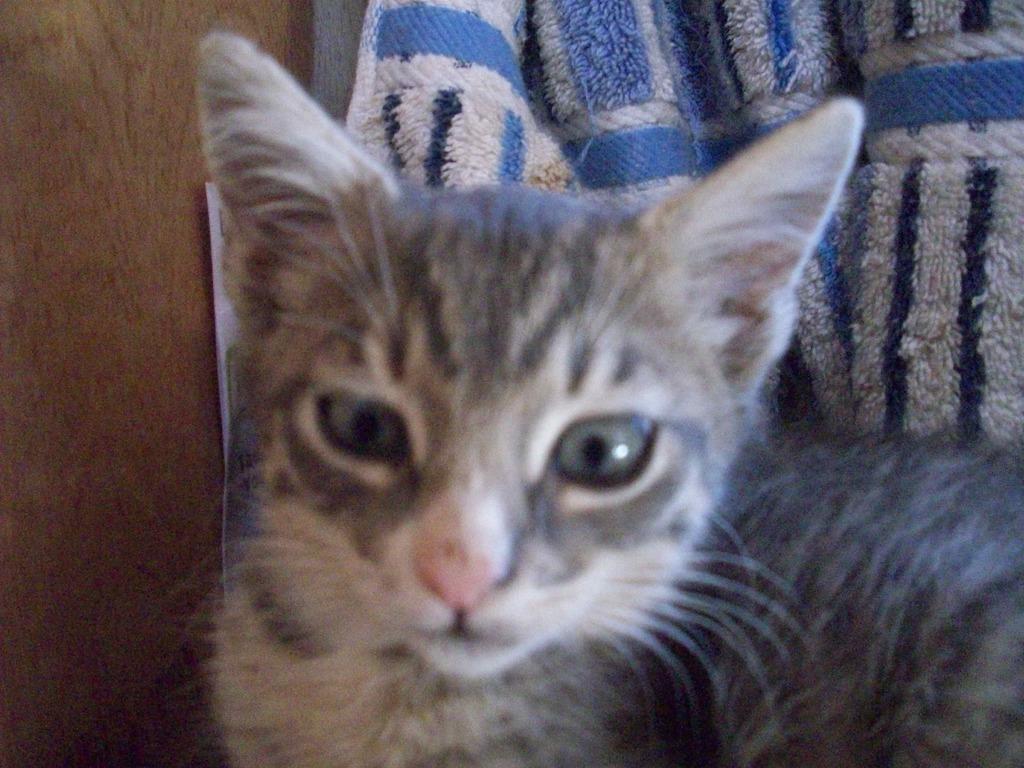How would you summarize this image in a sentence or two? In this image there is a cat , and in the background there is a cloth and a wooden board. 